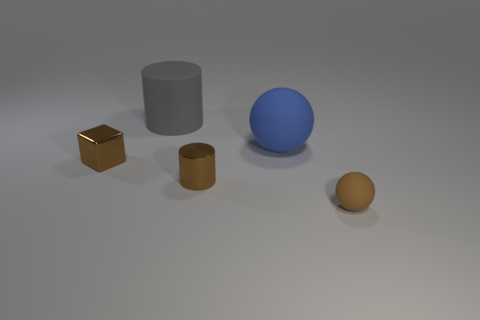Add 4 brown matte spheres. How many objects exist? 9 Subtract all spheres. How many objects are left? 3 Subtract 1 brown cylinders. How many objects are left? 4 Subtract all rubber things. Subtract all cylinders. How many objects are left? 0 Add 2 large gray cylinders. How many large gray cylinders are left? 3 Add 4 big cyan matte things. How many big cyan matte things exist? 4 